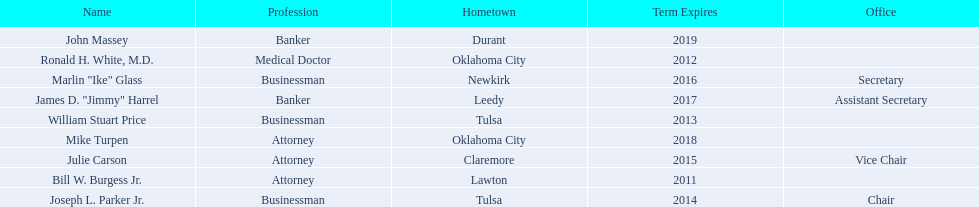Give me the full table as a dictionary. {'header': ['Name', 'Profession', 'Hometown', 'Term Expires', 'Office'], 'rows': [['John Massey', 'Banker', 'Durant', '2019', ''], ['Ronald H. White, M.D.', 'Medical Doctor', 'Oklahoma City', '2012', ''], ['Marlin "Ike" Glass', 'Businessman', 'Newkirk', '2016', 'Secretary'], ['James D. "Jimmy" Harrel', 'Banker', 'Leedy', '2017', 'Assistant Secretary'], ['William Stuart Price', 'Businessman', 'Tulsa', '2013', ''], ['Mike Turpen', 'Attorney', 'Oklahoma City', '2018', ''], ['Julie Carson', 'Attorney', 'Claremore', '2015', 'Vice Chair'], ['Bill W. Burgess Jr.', 'Attorney', 'Lawton', '2011', ''], ['Joseph L. Parker Jr.', 'Businessman', 'Tulsa', '2014', 'Chair']]} Which state regent is from the same hometown as ronald h. white, m.d.? Mike Turpen. 